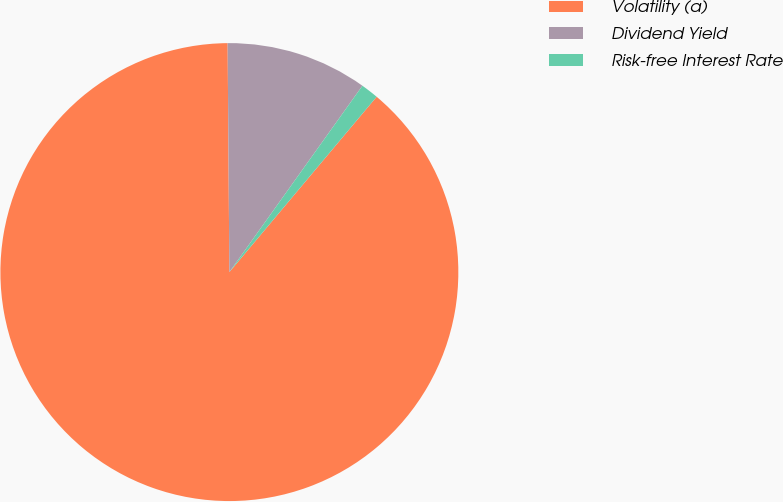<chart> <loc_0><loc_0><loc_500><loc_500><pie_chart><fcel>Volatility (a)<fcel>Dividend Yield<fcel>Risk-free Interest Rate<nl><fcel>88.76%<fcel>9.99%<fcel>1.25%<nl></chart> 